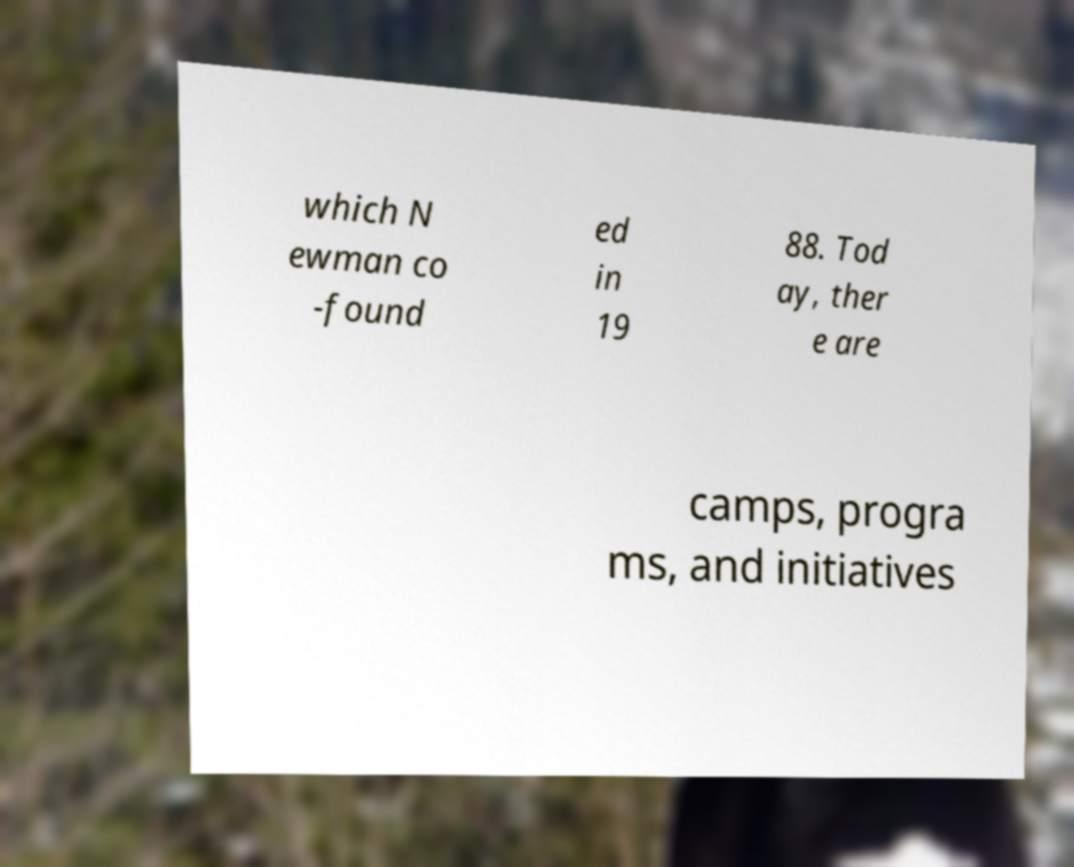Please identify and transcribe the text found in this image. which N ewman co -found ed in 19 88. Tod ay, ther e are camps, progra ms, and initiatives 